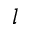<formula> <loc_0><loc_0><loc_500><loc_500>l</formula> 